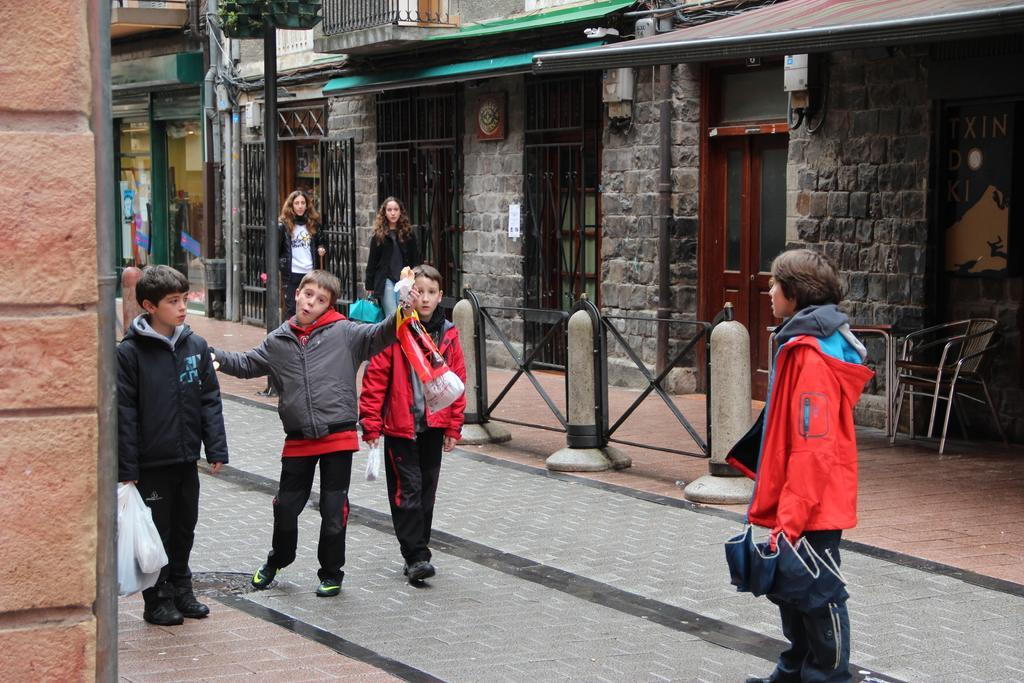Can you describe this image briefly? On the left side of the image we can see a boy is standing and holding something in his hand, a pipe and a wall is there. In the middle of the image we can see two kids and two ladies. On the right side of the image we can see a boy is standing and holding something in his hand and a chair is there. 